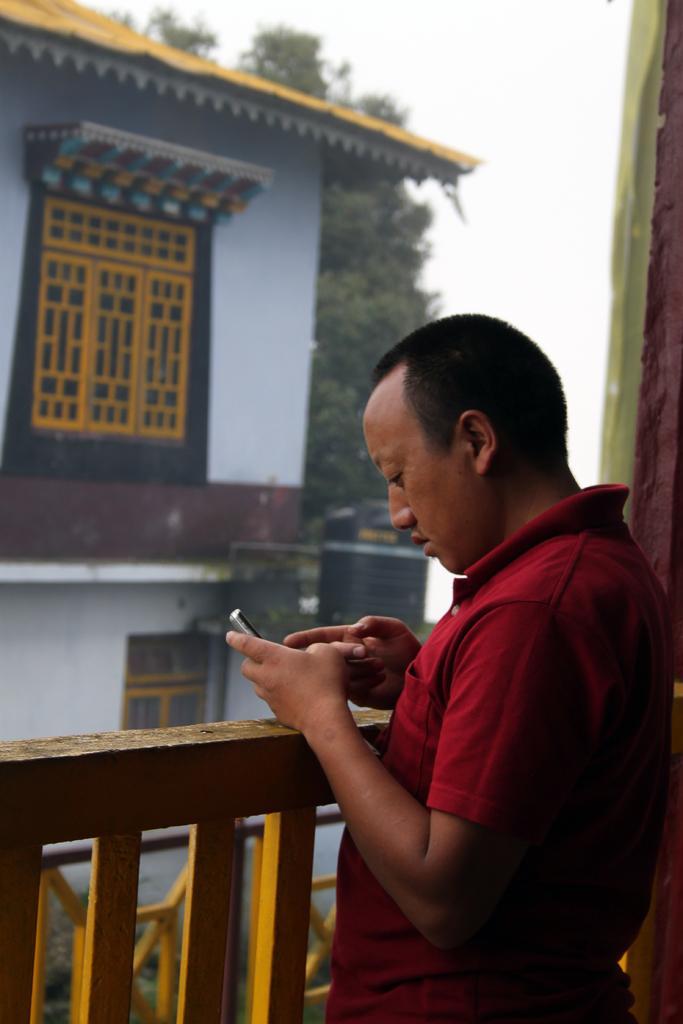Could you give a brief overview of what you see in this image? In the center of the image we can see a person is standing and he is holding some object. On the right side of the image, there is a wall. In front of him, there is a fence. In the background, we can see the sky, one building, windows, one tree and a few other objects. 